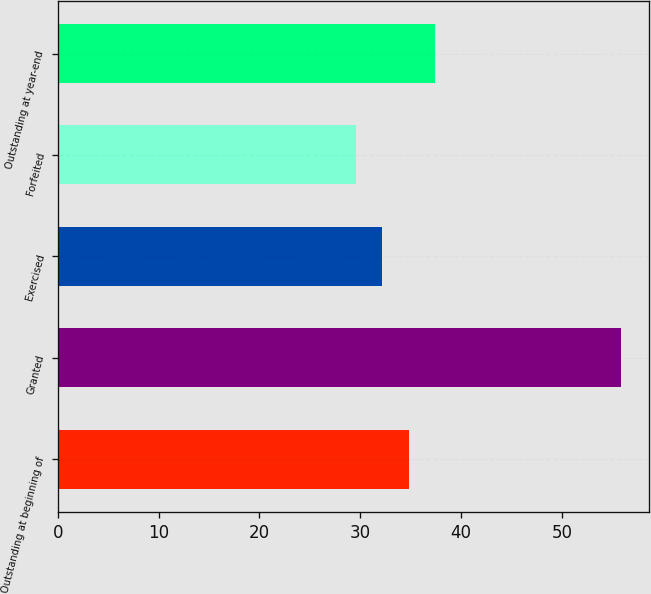<chart> <loc_0><loc_0><loc_500><loc_500><bar_chart><fcel>Outstanding at beginning of<fcel>Granted<fcel>Exercised<fcel>Forfeited<fcel>Outstanding at year-end<nl><fcel>34.79<fcel>55.86<fcel>32.16<fcel>29.53<fcel>37.42<nl></chart> 